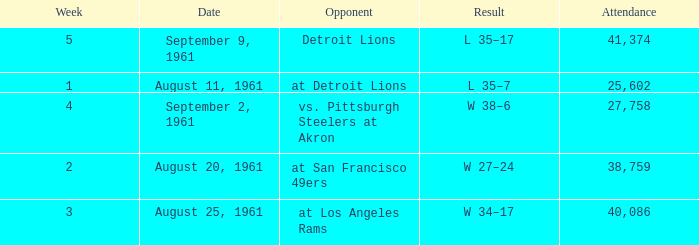What was the score of the Browns week 4 game? W 38–6. 